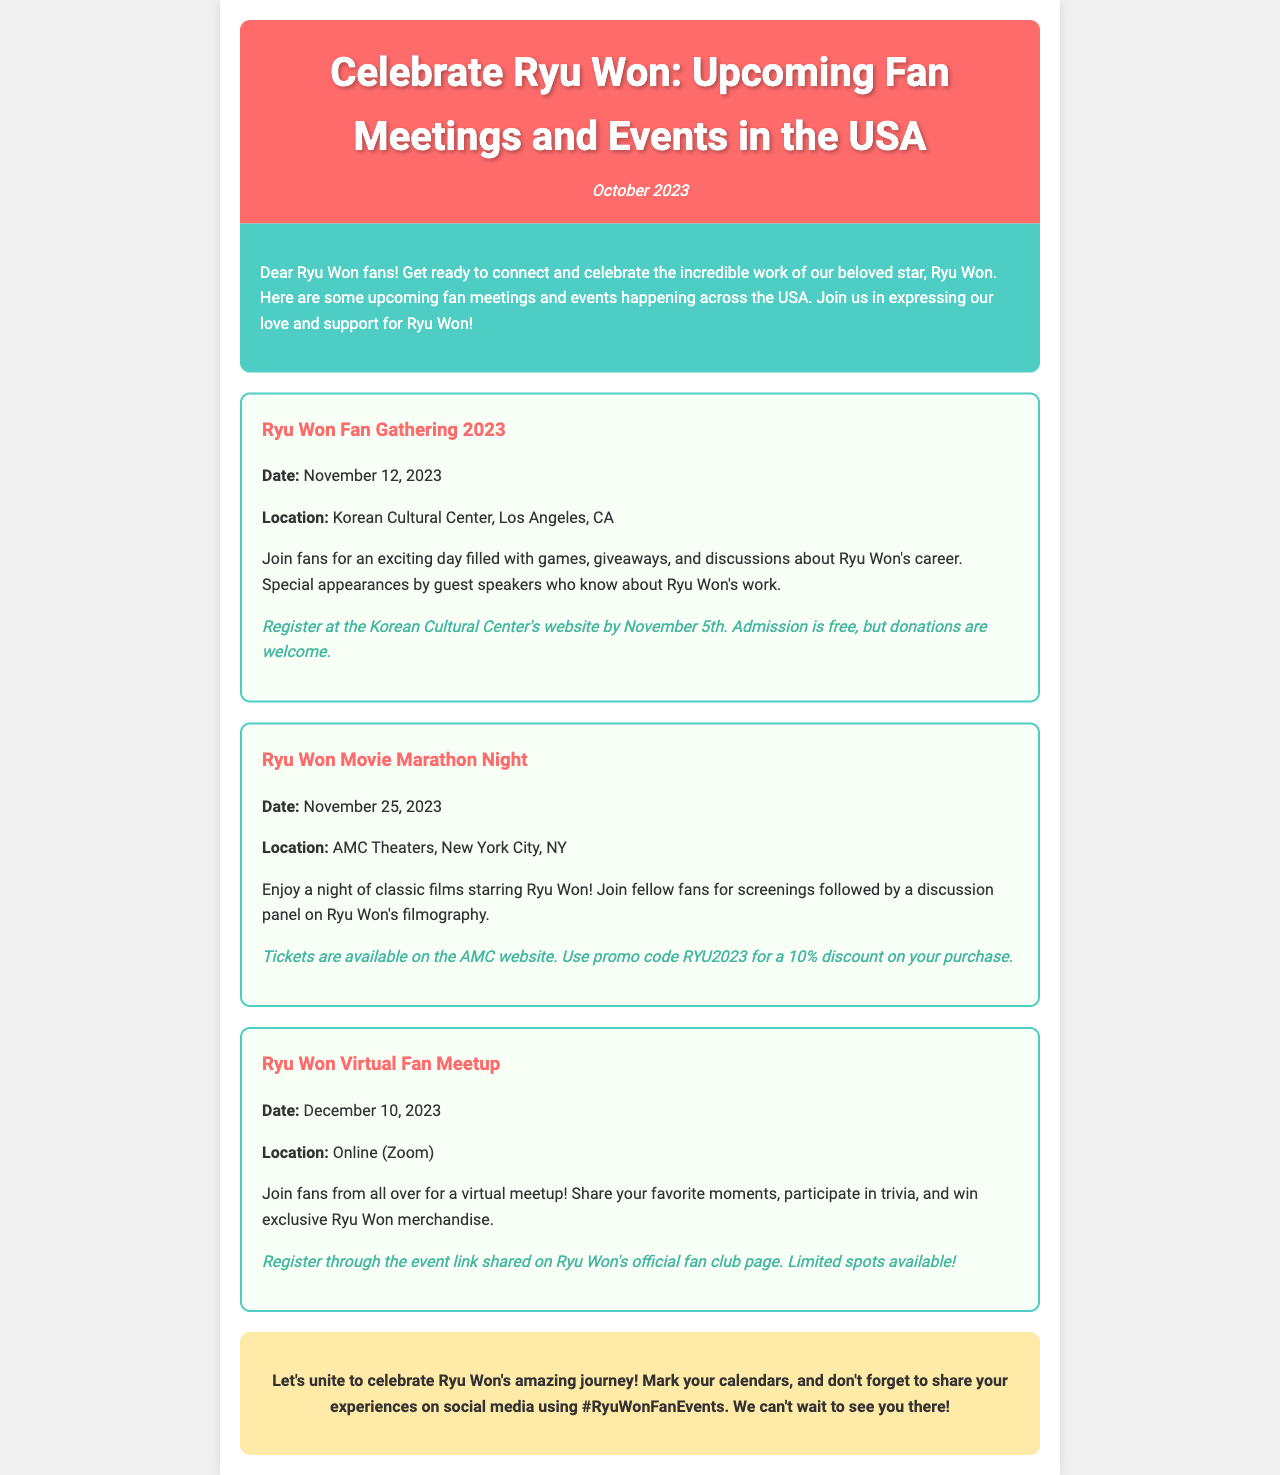What is the date for the Ryu Won Fan Gathering? The date for the Ryu Won Fan Gathering is mentioned in the event details as November 12, 2023.
Answer: November 12, 2023 Where is the Ryu Won Movie Marathon Night taking place? The location for the Ryu Won Movie Marathon Night is provided in the event details as AMC Theaters, New York City, NY.
Answer: AMC Theaters, New York City, NY What special feature will occur during the Ryu Won Fan Gathering? The event details mention that there will be special appearances by guest speakers who know about Ryu Won's work.
Answer: Guest speakers What is the registration deadline for the Ryu Won Fan Gathering? The document states that registration at the Korean Cultural Center's website must be completed by November 5th.
Answer: November 5th What is required to participate in the Ryu Won Virtual Fan Meetup? The document indicates that fans need to register through the event link shared on Ryu Won's official fan club page to participate.
Answer: Register online How can fans receive a discount for the Ryu Won Movie Marathon Night tickets? The document mentions using promo code RYU2023 for a 10% discount on tickets purchased through the AMC website.
Answer: RYU2023 What type of activities will occur at the Ryu Won Virtual Fan Meetup? According to the event details, fans will share favorite moments, participate in trivia, and win exclusive Ryu Won merchandise.
Answer: Trivia and sharing moments What should fans use on social media to share their experiences? The newsletter encourages fans to use the hashtag #RyuWonFanEvents on social media to share their experiences.
Answer: #RyuWonFanEvents 